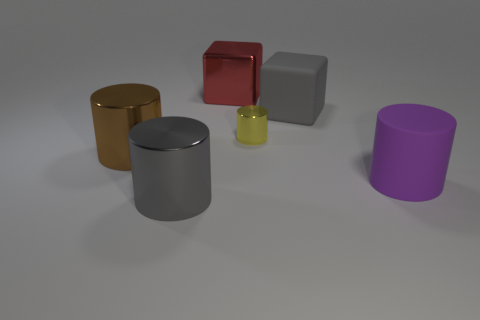There is a matte cube; is it the same color as the cylinder that is behind the brown shiny thing?
Offer a terse response. No. Are there any large gray objects that have the same shape as the purple rubber thing?
Ensure brevity in your answer.  Yes. How many things are either large yellow cylinders or large things that are behind the purple cylinder?
Your response must be concise. 3. How many other objects are the same material as the brown cylinder?
Keep it short and to the point. 3. What number of things are either matte cubes or gray cylinders?
Provide a succinct answer. 2. Are there more shiny things that are to the left of the red cube than big metallic things in front of the purple cylinder?
Your answer should be compact. Yes. Is the color of the large cube to the right of the tiny cylinder the same as the matte object in front of the tiny yellow shiny cylinder?
Your response must be concise. No. There is a object behind the large matte object that is behind the big cylinder right of the shiny block; what is its size?
Provide a short and direct response. Large. There is another big rubber object that is the same shape as the brown object; what color is it?
Keep it short and to the point. Purple. Is the number of large gray things in front of the tiny cylinder greater than the number of blue cylinders?
Provide a short and direct response. Yes. 